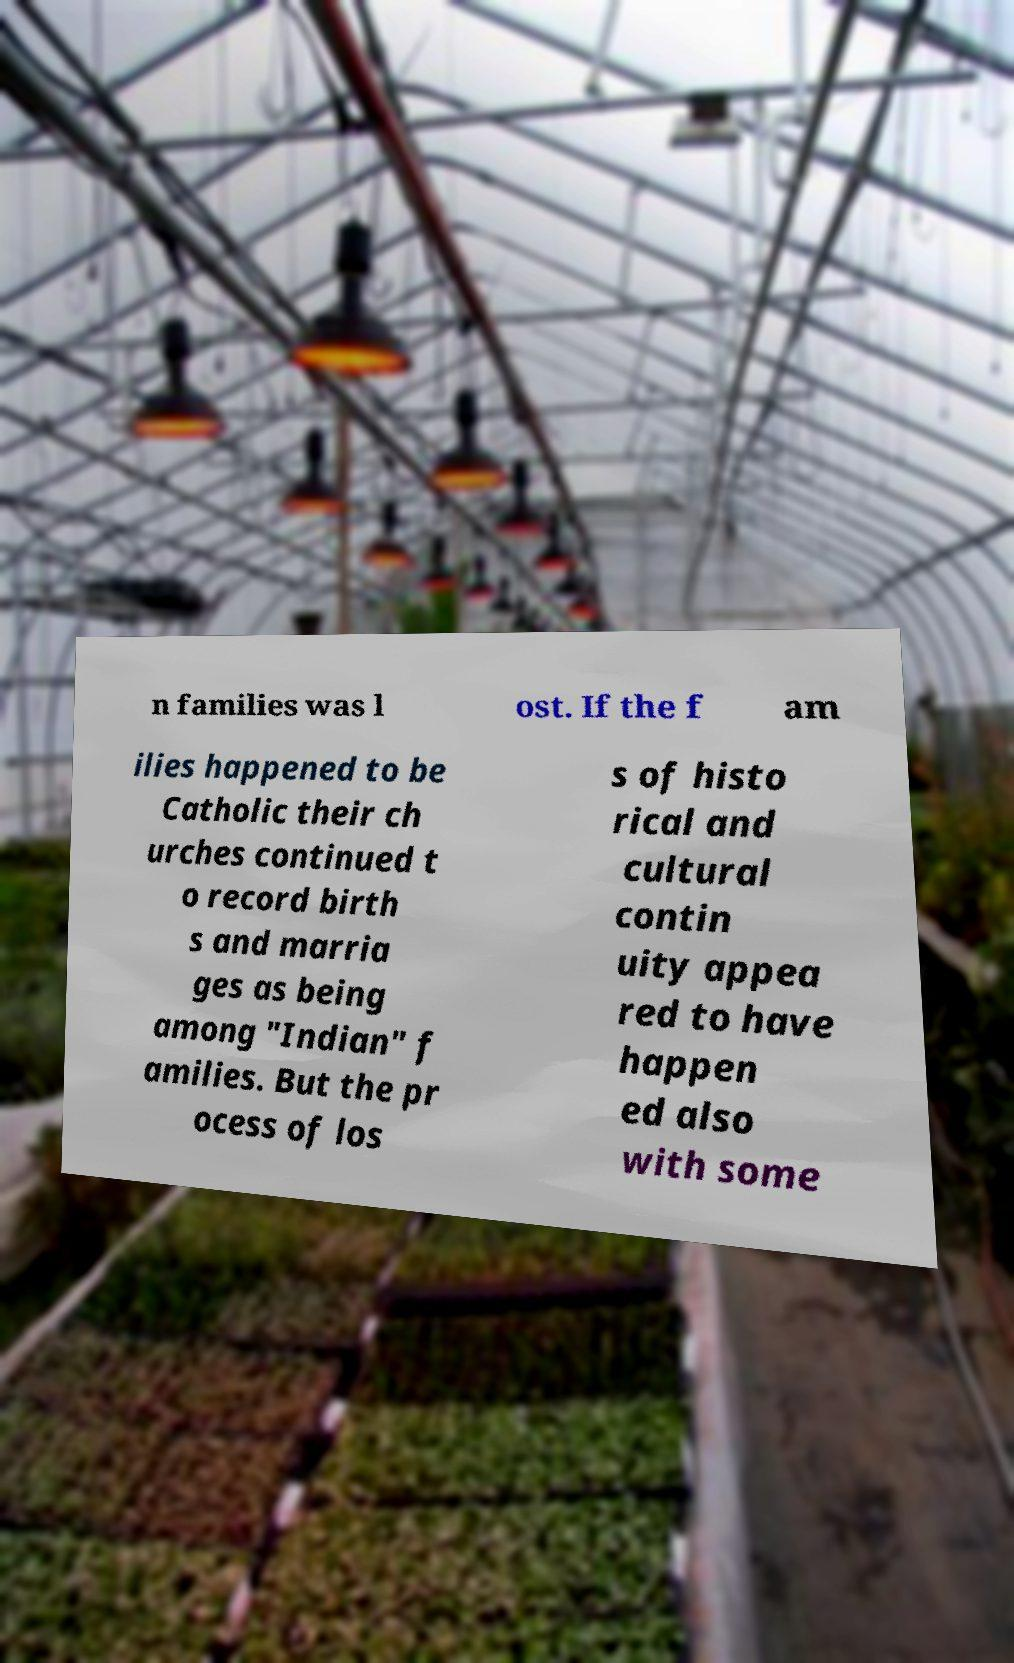Could you extract and type out the text from this image? n families was l ost. If the f am ilies happened to be Catholic their ch urches continued t o record birth s and marria ges as being among "Indian" f amilies. But the pr ocess of los s of histo rical and cultural contin uity appea red to have happen ed also with some 